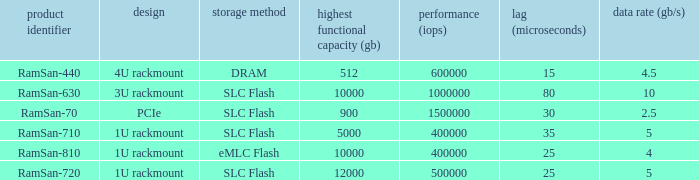Can you provide the number of input/output operations per second for emlc flash storage? 400000.0. 